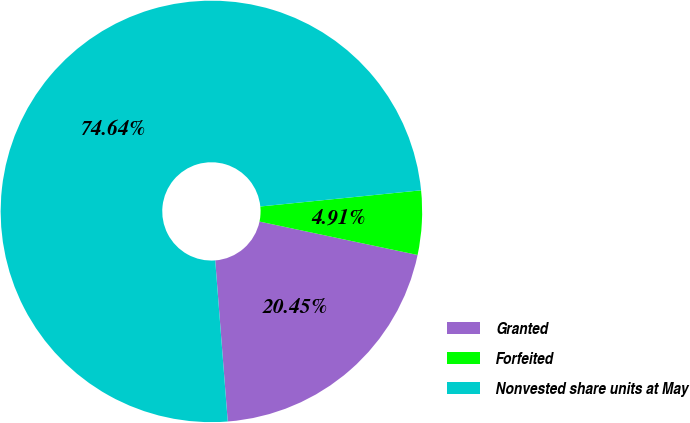<chart> <loc_0><loc_0><loc_500><loc_500><pie_chart><fcel>Granted<fcel>Forfeited<fcel>Nonvested share units at May<nl><fcel>20.45%<fcel>4.91%<fcel>74.64%<nl></chart> 